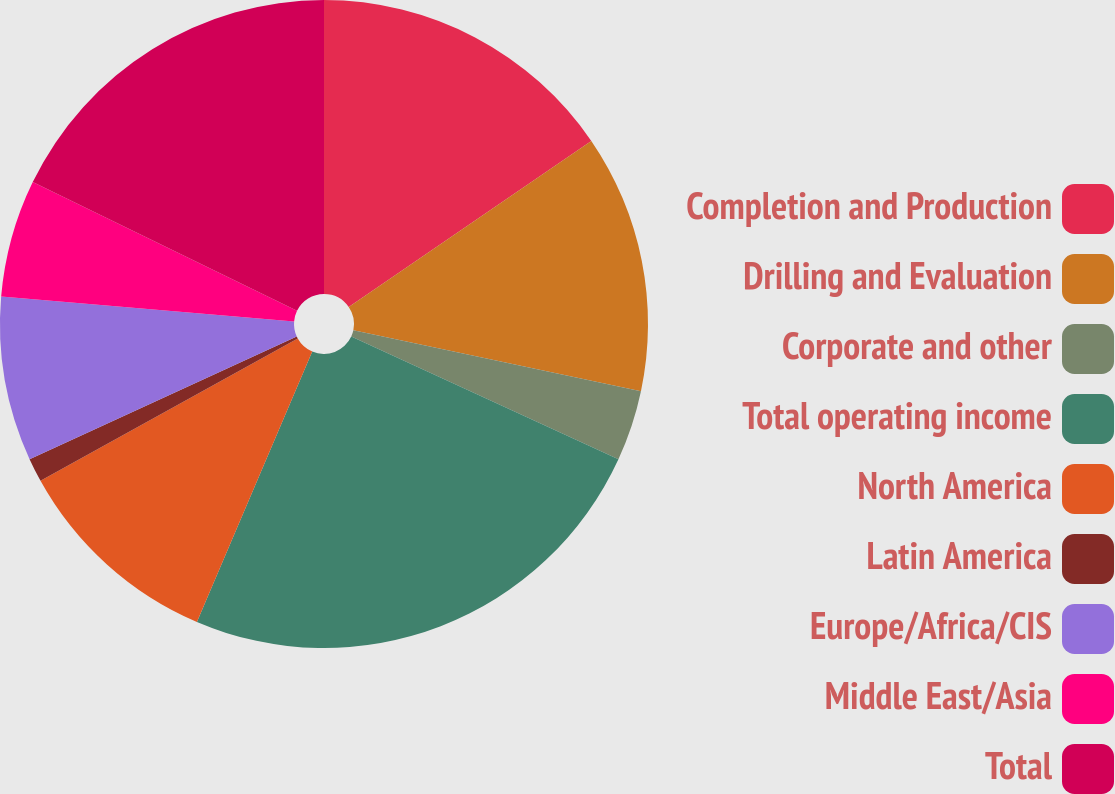<chart> <loc_0><loc_0><loc_500><loc_500><pie_chart><fcel>Completion and Production<fcel>Drilling and Evaluation<fcel>Corporate and other<fcel>Total operating income<fcel>North America<fcel>Latin America<fcel>Europe/Africa/CIS<fcel>Middle East/Asia<fcel>Total<nl><fcel>15.44%<fcel>12.88%<fcel>3.53%<fcel>24.56%<fcel>10.54%<fcel>1.19%<fcel>8.2%<fcel>5.87%<fcel>17.78%<nl></chart> 